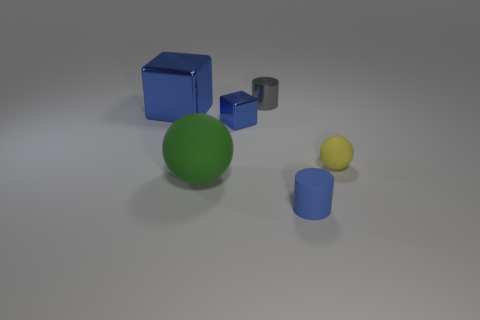Add 2 small rubber things. How many objects exist? 8 Subtract all cylinders. How many objects are left? 4 Add 4 small blue shiny things. How many small blue shiny things are left? 5 Add 2 green rubber balls. How many green rubber balls exist? 3 Subtract 0 purple cylinders. How many objects are left? 6 Subtract all tiny cubes. Subtract all tiny cyan spheres. How many objects are left? 5 